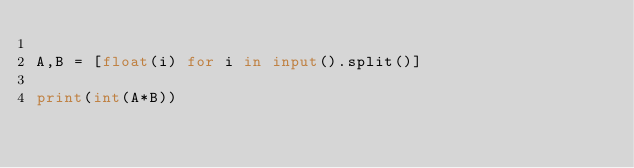<code> <loc_0><loc_0><loc_500><loc_500><_Python_>
A,B = [float(i) for i in input().split()]

print(int(A*B))</code> 